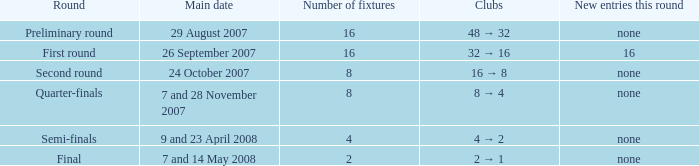When there are more than two fixtures in a round, what is the main date for the 7th and 28th of november 2007? Quarter-finals. 